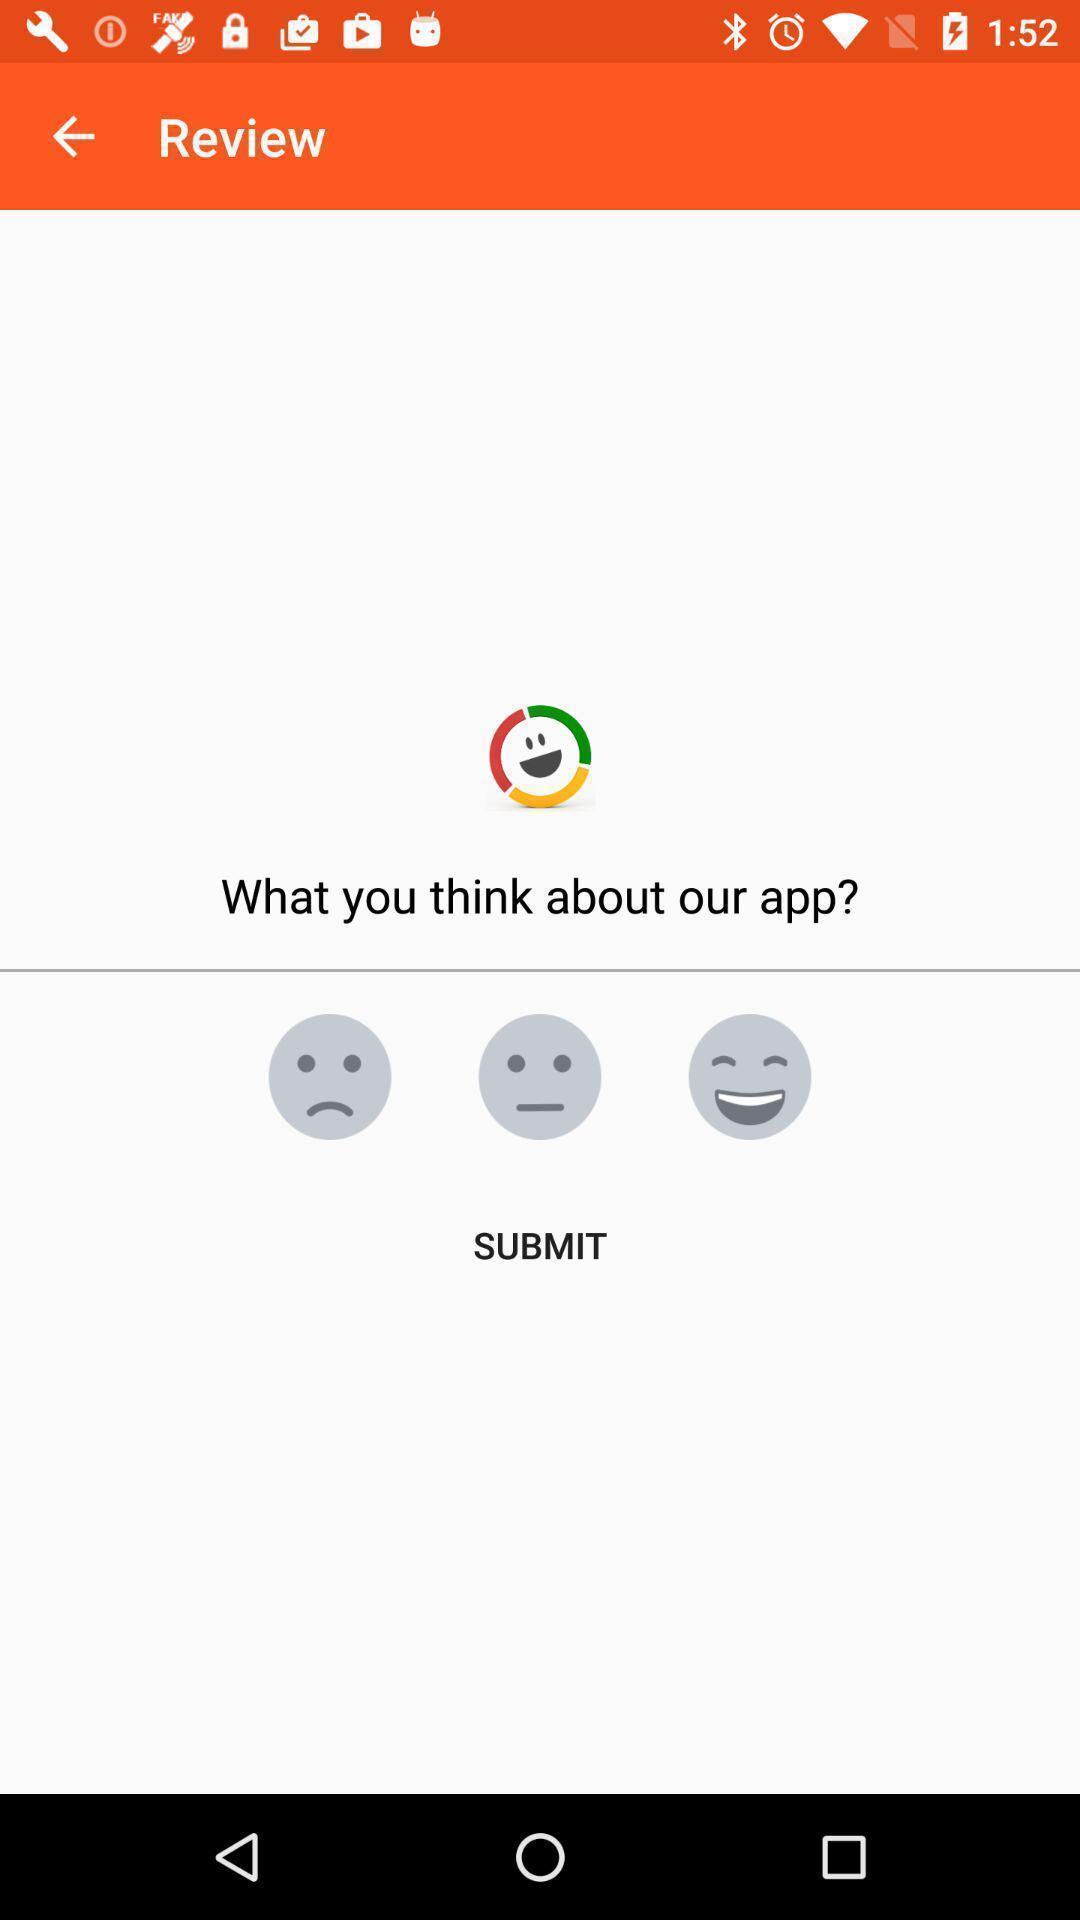Summarize the main components in this picture. Review tab in the application with question. 